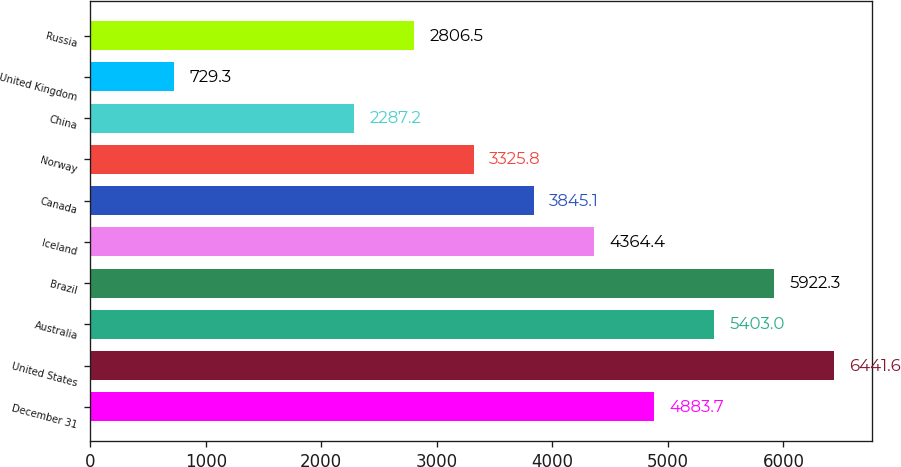Convert chart to OTSL. <chart><loc_0><loc_0><loc_500><loc_500><bar_chart><fcel>December 31<fcel>United States<fcel>Australia<fcel>Brazil<fcel>Iceland<fcel>Canada<fcel>Norway<fcel>China<fcel>United Kingdom<fcel>Russia<nl><fcel>4883.7<fcel>6441.6<fcel>5403<fcel>5922.3<fcel>4364.4<fcel>3845.1<fcel>3325.8<fcel>2287.2<fcel>729.3<fcel>2806.5<nl></chart> 